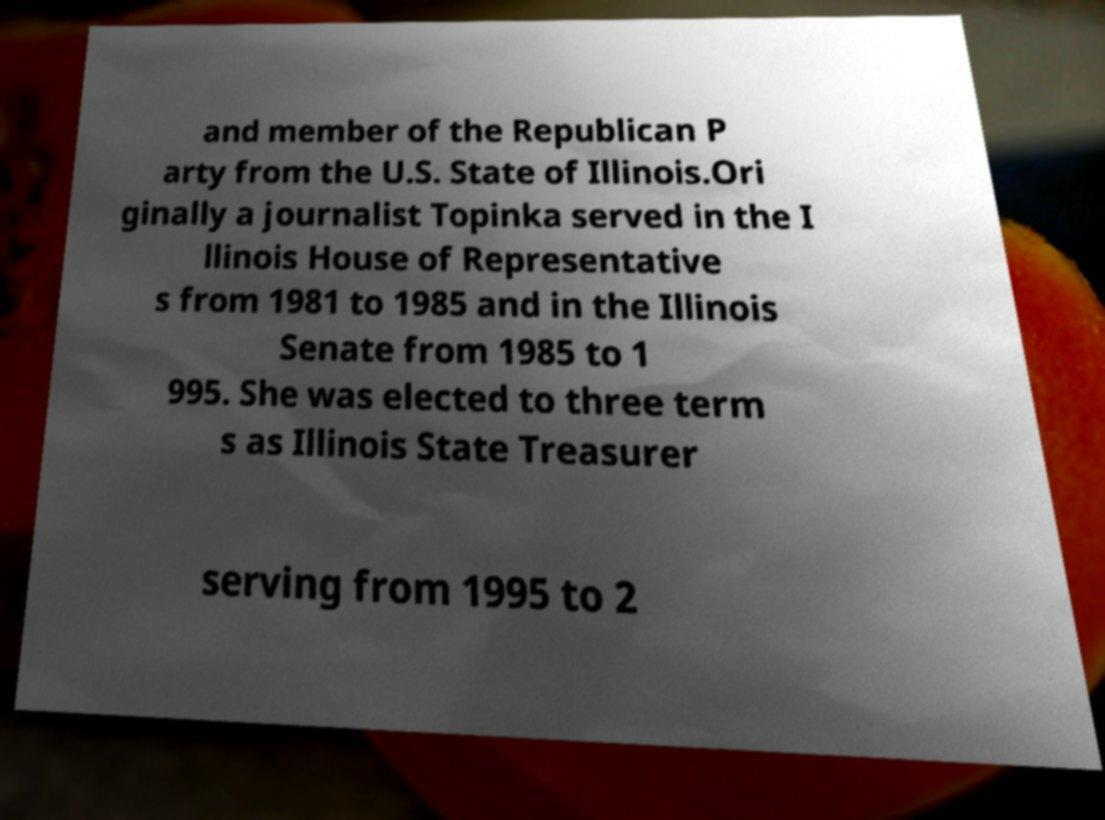Could you extract and type out the text from this image? and member of the Republican P arty from the U.S. State of Illinois.Ori ginally a journalist Topinka served in the I llinois House of Representative s from 1981 to 1985 and in the Illinois Senate from 1985 to 1 995. She was elected to three term s as Illinois State Treasurer serving from 1995 to 2 